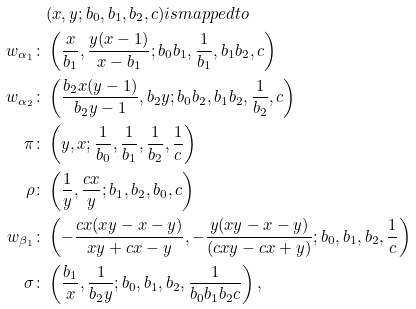<formula> <loc_0><loc_0><loc_500><loc_500>& ( x , y ; b _ { 0 } , b _ { 1 } , b _ { 2 } , c ) i s m a p p e d t o \\ w _ { \alpha _ { 1 } } \colon & \left ( \frac { x } { b _ { 1 } } , \frac { y ( x - 1 ) } { x - b _ { 1 } } ; b _ { 0 } b _ { 1 } , \frac { 1 } { b _ { 1 } } , b _ { 1 } b _ { 2 } , c \right ) \\ w _ { \alpha _ { 2 } } \colon & \left ( \frac { b _ { 2 } x ( y - 1 ) } { b _ { 2 } y - 1 } , b _ { 2 } y ; b _ { 0 } b _ { 2 } , b _ { 1 } b _ { 2 } , \frac { 1 } { b _ { 2 } } , c \right ) \\ \pi \colon & \left ( y , x ; \frac { 1 } { b _ { 0 } } , \frac { 1 } { b _ { 1 } } , \frac { 1 } { b _ { 2 } } , \frac { 1 } { c } \right ) \\ \rho \colon & \left ( \frac { 1 } { y } , \frac { c x } { y } ; b _ { 1 } , b _ { 2 } , b _ { 0 } , c \right ) \\ w _ { \beta _ { 1 } } \colon & \left ( - \frac { c x ( x y - x - y ) } { x y + c x - y } , - \frac { y ( x y - x - y ) } { ( c x y - c x + y ) } ; b _ { 0 } , b _ { 1 } , b _ { 2 } , \frac { 1 } { c } \right ) \\ \sigma \colon & \left ( \frac { b _ { 1 } } { x } , \frac { 1 } { b _ { 2 } y } ; b _ { 0 } , b _ { 1 } , b _ { 2 } , \frac { 1 } { b _ { 0 } b _ { 1 } b _ { 2 } c } \right ) ,</formula> 